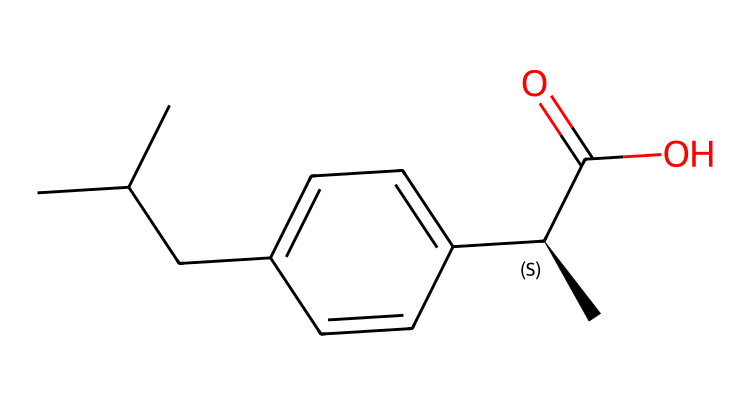What is the molecular formula of ibuprofen? To derive the molecular formula from the SMILES representation, we count the carbon (C), hydrogen (H), and oxygen (O) atoms present in the structure. The SMILES indicates 13 carbon atoms, 18 hydrogen atoms, and 2 oxygen atoms, which gives us the formula C13H18O2.
Answer: C13H18O2 How many rings does ibuprofen have in its structure? The SMILES representation indicates a benzene ring (due to the 'cc' notation), but there are no other rings present. Since there is only one aromatic ring visible in the structure, ibuprofen contains one ring.
Answer: one What functional groups are present in ibuprofen? Analyzing the SMILES, we identify the carboxylic acid group (–C(=O)O) and the aromatic ring present in the structure. The presence of these groups confirms that ibuprofen has at least these two functional groups.
Answer: carboxylic acid and aromatic What is the stereochemistry at the chiral center in ibuprofen? The notation "[C@H]" in the SMILES indicates a chiral center, showing that there is a specific 3D orientation (R or S configuration) at that carbon atom. It is specified directly by the '@' symbol indicating a single stereocenter in the structure.
Answer: chiral What type of solid does ibuprofen form at room temperature? Based on the molecular structure and properties of ibuprofen, including its melting point and crystallinity, we determine that it is classified as a crystalline solid.
Answer: crystalline How does the structure of ibuprofen relate to its function as an NSAID? The structure includes an aromatic ring and a carboxylic acid, which are key for its anti-inflammatory activity due to the inhibition of the cyclooxygenase enzymes. This structural information helps explain its mechanism of action as an NSAID.
Answer: anti-inflammatory activity 